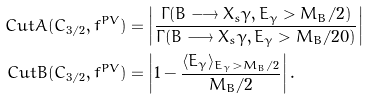Convert formula to latex. <formula><loc_0><loc_0><loc_500><loc_500>C u t A ( C _ { 3 / 2 } , f ^ { P V } ) & = \left | \frac { \Gamma ( \bar { B } \longrightarrow X _ { s } \gamma , E _ { \gamma } > M _ { B } / 2 ) } { \Gamma ( \bar { B } \longrightarrow X _ { s } \gamma , E _ { \gamma } > M _ { B } / 2 0 ) } \right | \\ C u t B ( C _ { 3 / 2 } , f ^ { P V } ) & = \left | 1 - \frac { \langle E _ { \gamma } \rangle _ { E _ { \gamma } > M _ { B } / 2 } } { M _ { B } / 2 } \right | .</formula> 